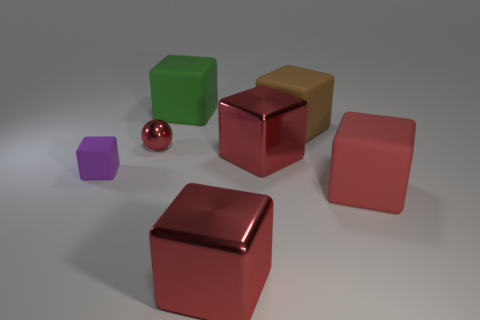Subtract all red cubes. How many were subtracted if there are1red cubes left? 2 Subtract all red balls. How many red cubes are left? 3 Subtract all purple matte cubes. How many cubes are left? 5 Subtract all purple cubes. How many cubes are left? 5 Subtract all yellow blocks. Subtract all blue cylinders. How many blocks are left? 6 Add 1 tiny red cylinders. How many objects exist? 8 Subtract all blocks. How many objects are left? 1 Subtract all large yellow rubber blocks. Subtract all red shiny blocks. How many objects are left? 5 Add 1 rubber objects. How many rubber objects are left? 5 Add 1 big cyan rubber cylinders. How many big cyan rubber cylinders exist? 1 